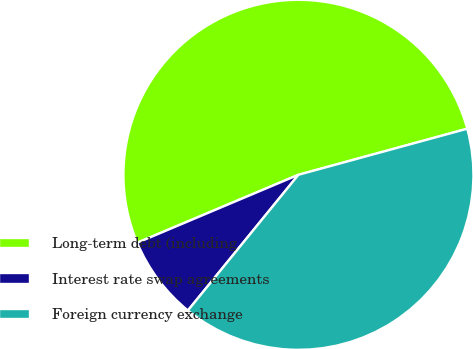Convert chart to OTSL. <chart><loc_0><loc_0><loc_500><loc_500><pie_chart><fcel>Long-term debt (including<fcel>Interest rate swap agreements<fcel>Foreign currency exchange<nl><fcel>52.11%<fcel>7.77%<fcel>40.12%<nl></chart> 